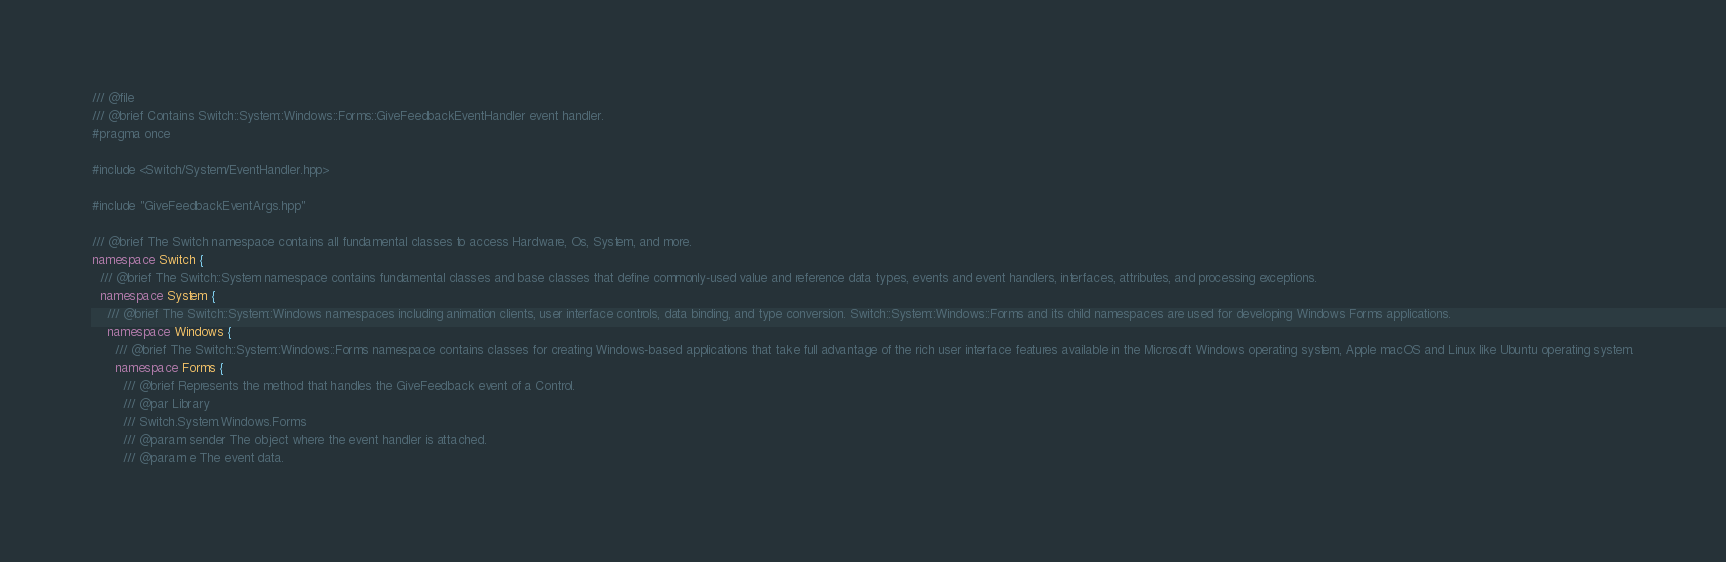<code> <loc_0><loc_0><loc_500><loc_500><_C++_>/// @file
/// @brief Contains Switch::System::Windows::Forms::GiveFeedbackEventHandler event handler.
#pragma once

#include <Switch/System/EventHandler.hpp>

#include "GiveFeedbackEventArgs.hpp"

/// @brief The Switch namespace contains all fundamental classes to access Hardware, Os, System, and more.
namespace Switch {
  /// @brief The Switch::System namespace contains fundamental classes and base classes that define commonly-used value and reference data types, events and event handlers, interfaces, attributes, and processing exceptions.
  namespace System {
    /// @brief The Switch::System::Windows namespaces including animation clients, user interface controls, data binding, and type conversion. Switch::System::Windows::Forms and its child namespaces are used for developing Windows Forms applications.
    namespace Windows {
      /// @brief The Switch::System::Windows::Forms namespace contains classes for creating Windows-based applications that take full advantage of the rich user interface features available in the Microsoft Windows operating system, Apple macOS and Linux like Ubuntu operating system.
      namespace Forms {
        /// @brief Represents the method that handles the GiveFeedback event of a Control.
        /// @par Library
        /// Switch.System.Windows.Forms
        /// @param sender The object where the event handler is attached.
        /// @param e The event data.</code> 